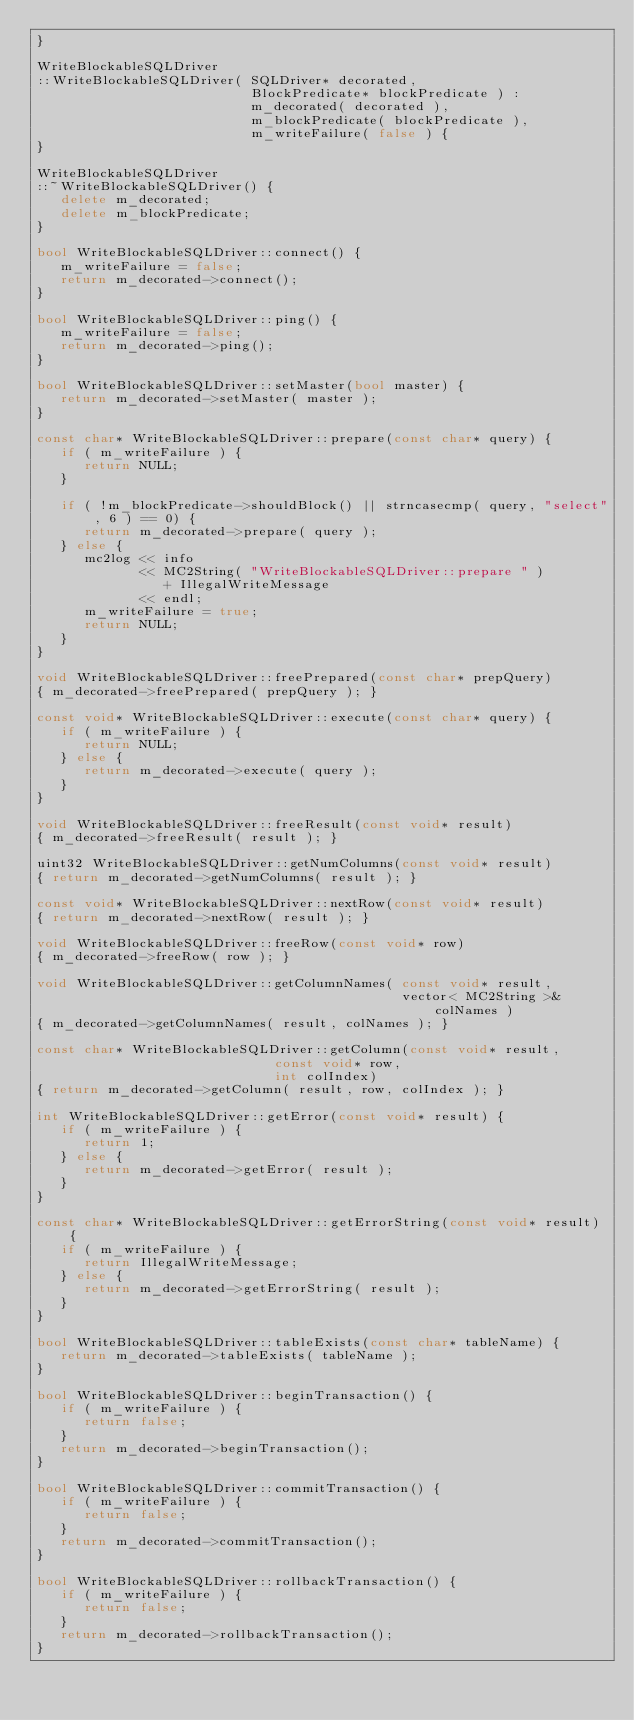Convert code to text. <code><loc_0><loc_0><loc_500><loc_500><_C++_>}

WriteBlockableSQLDriver
::WriteBlockableSQLDriver( SQLDriver* decorated, 
                           BlockPredicate* blockPredicate ) :
                           m_decorated( decorated ),
                           m_blockPredicate( blockPredicate ),
                           m_writeFailure( false ) {
}

WriteBlockableSQLDriver
::~WriteBlockableSQLDriver() {
   delete m_decorated;
   delete m_blockPredicate;
}
                            
bool WriteBlockableSQLDriver::connect() { 
   m_writeFailure = false;
   return m_decorated->connect(); 
}

bool WriteBlockableSQLDriver::ping() { 
   m_writeFailure = false;
   return m_decorated->ping(); 
}

bool WriteBlockableSQLDriver::setMaster(bool master) { 
   return m_decorated->setMaster( master ); 
}

const char* WriteBlockableSQLDriver::prepare(const char* query) {
   if ( m_writeFailure ) {
      return NULL;
   }

   if ( !m_blockPredicate->shouldBlock() || strncasecmp( query, "select", 6 ) == 0) {
      return m_decorated->prepare( query );
   } else {
      mc2log << info 
             << MC2String( "WriteBlockableSQLDriver::prepare " ) 
                + IllegalWriteMessage 
             << endl;
      m_writeFailure = true;
      return NULL;
   }
}

void WriteBlockableSQLDriver::freePrepared(const char* prepQuery) 
{ m_decorated->freePrepared( prepQuery ); }

const void* WriteBlockableSQLDriver::execute(const char* query) { 
   if ( m_writeFailure ) {
      return NULL;
   } else {
      return m_decorated->execute( query );
   }
}

void WriteBlockableSQLDriver::freeResult(const void* result) 
{ m_decorated->freeResult( result ); }

uint32 WriteBlockableSQLDriver::getNumColumns(const void* result) 
{ return m_decorated->getNumColumns( result ); }

const void* WriteBlockableSQLDriver::nextRow(const void* result) 
{ return m_decorated->nextRow( result ); }

void WriteBlockableSQLDriver::freeRow(const void* row) 
{ m_decorated->freeRow( row ); }

void WriteBlockableSQLDriver::getColumnNames( const void* result, 
                                              vector< MC2String >& colNames ) 
{ m_decorated->getColumnNames( result, colNames ); }

const char* WriteBlockableSQLDriver::getColumn(const void* result,
                              const void* row,
                              int colIndex) 
{ return m_decorated->getColumn( result, row, colIndex ); }

int WriteBlockableSQLDriver::getError(const void* result) { 
   if ( m_writeFailure ) {
      return 1;
   } else {
      return m_decorated->getError( result ); 
   }
}

const char* WriteBlockableSQLDriver::getErrorString(const void* result) { 
   if ( m_writeFailure ) {
      return IllegalWriteMessage;
   } else {
      return m_decorated->getErrorString( result ); 
   }
}

bool WriteBlockableSQLDriver::tableExists(const char* tableName) { 
   return m_decorated->tableExists( tableName ); 
}

bool WriteBlockableSQLDriver::beginTransaction() { 
   if ( m_writeFailure ) {
      return false;
   }
   return m_decorated->beginTransaction(); 
}

bool WriteBlockableSQLDriver::commitTransaction() { 
   if ( m_writeFailure ) {
      return false;
   }
   return m_decorated->commitTransaction(); 
}

bool WriteBlockableSQLDriver::rollbackTransaction() { 
   if ( m_writeFailure ) {
      return false;
   }
   return m_decorated->rollbackTransaction(); 
}
</code> 